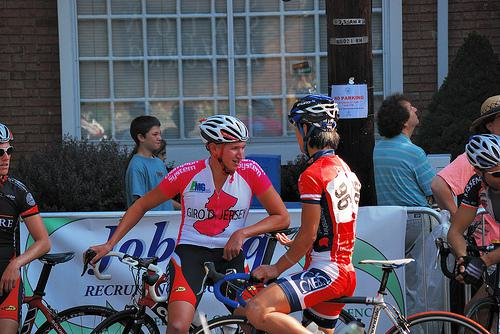What are the cyclists discussing? The cyclists might be discussing race strategies or sharing their experiences about the ongoing event. The focused expressions suggest a conversation around performance or possibly event challenges. 